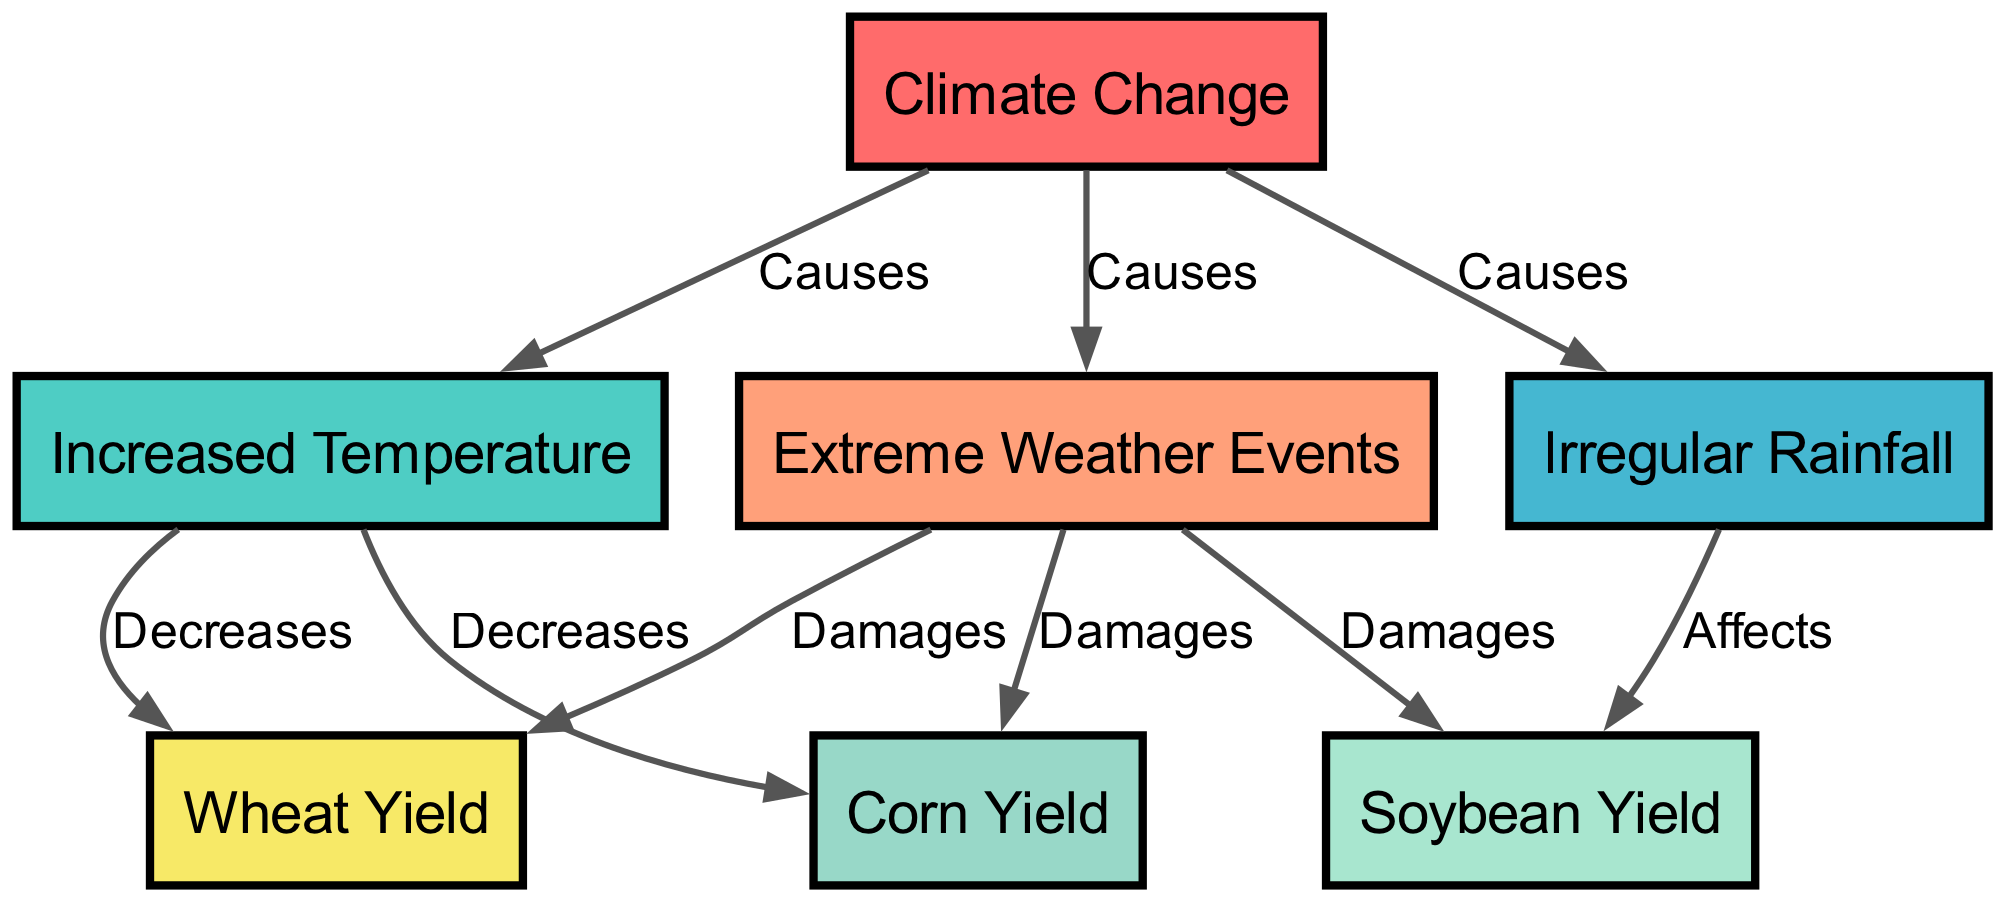What is the main cause in the diagram? The diagram identifies "Climate Change" as the primary node (or cause) from which all other connections originate. It is clearly stated at the top of the diagram and connects to multiple factors like "Increased Temperature," "Irregular Rainfall," and "Extreme Weather Events."
Answer: Climate Change How many crop yield nodes are present in the diagram? The diagram includes three crop yield nodes: "Corn Yield," "Wheat Yield," and "Soybean Yield." By counting the nodes listed, we can confirm the total.
Answer: 3 Which factor decreases both corn and wheat yields? The diagram shows that "Increased Temperature" is directly linked to both "Corn Yield" and "Wheat Yield," indicating that this factor has a decreasing impact on both yields.
Answer: Increased Temperature What type of events are damaging to all crop yields? The diagram indicates that "Extreme Weather Events" are linked to all three crop yield nodes ("Corn Yield," "Wheat Yield," and "Soybean Yield") with damaging effects, thus confirming their significant negative impact.
Answer: Extreme Weather Events How does irregular rainfall affect soybean yield? The diagram states that "Irregular Rainfall" has a direct connection labeled "Affects" leading to "Soybean Yield," indicating it has a noticeable impact on this crop's yield.
Answer: Affects What is the relationship between increased temperature and crop yields? The diagram specifies that "Increased Temperature" decreases both "Corn Yield" and "Wheat Yield." This demonstrates the negative influence of rising temperatures on these specific crops.
Answer: Decreases Which factor has the most damaging effects listed in the diagram? "Extreme Weather Events" are shown to damage all three types of crop yields (Corn, Wheat, and Soybean), highlighting this factor's widespread detrimental impact.
Answer: Extreme Weather Events Which yield is specifically affected by irregular rainfall? The diagram indicates that "Irregular Rainfall" specifically affects "Soybean Yield," as shown by its direct link labeled "Affects."
Answer: Soybean Yield 